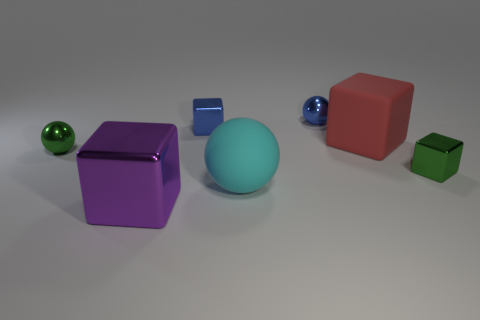Are there any big gray cylinders that have the same material as the blue ball?
Your answer should be very brief. No. Does the small green thing to the right of the purple metal object have the same material as the large red block?
Give a very brief answer. No. There is a ball that is both right of the purple metal cube and behind the tiny green metallic block; how big is it?
Offer a terse response. Small. The matte sphere has what color?
Your response must be concise. Cyan. What number of tiny blue things are there?
Your answer should be compact. 2. How many other things have the same color as the big metallic object?
Provide a short and direct response. 0. There is a blue object left of the big cyan thing; is it the same shape as the big red rubber thing that is right of the tiny green shiny ball?
Give a very brief answer. Yes. There is a shiny sphere that is on the right side of the big object that is in front of the rubber thing in front of the red thing; what is its color?
Your answer should be very brief. Blue. There is a big cube that is behind the large purple object; what color is it?
Offer a terse response. Red. There is a matte object that is the same size as the red matte cube; what color is it?
Your answer should be very brief. Cyan. 